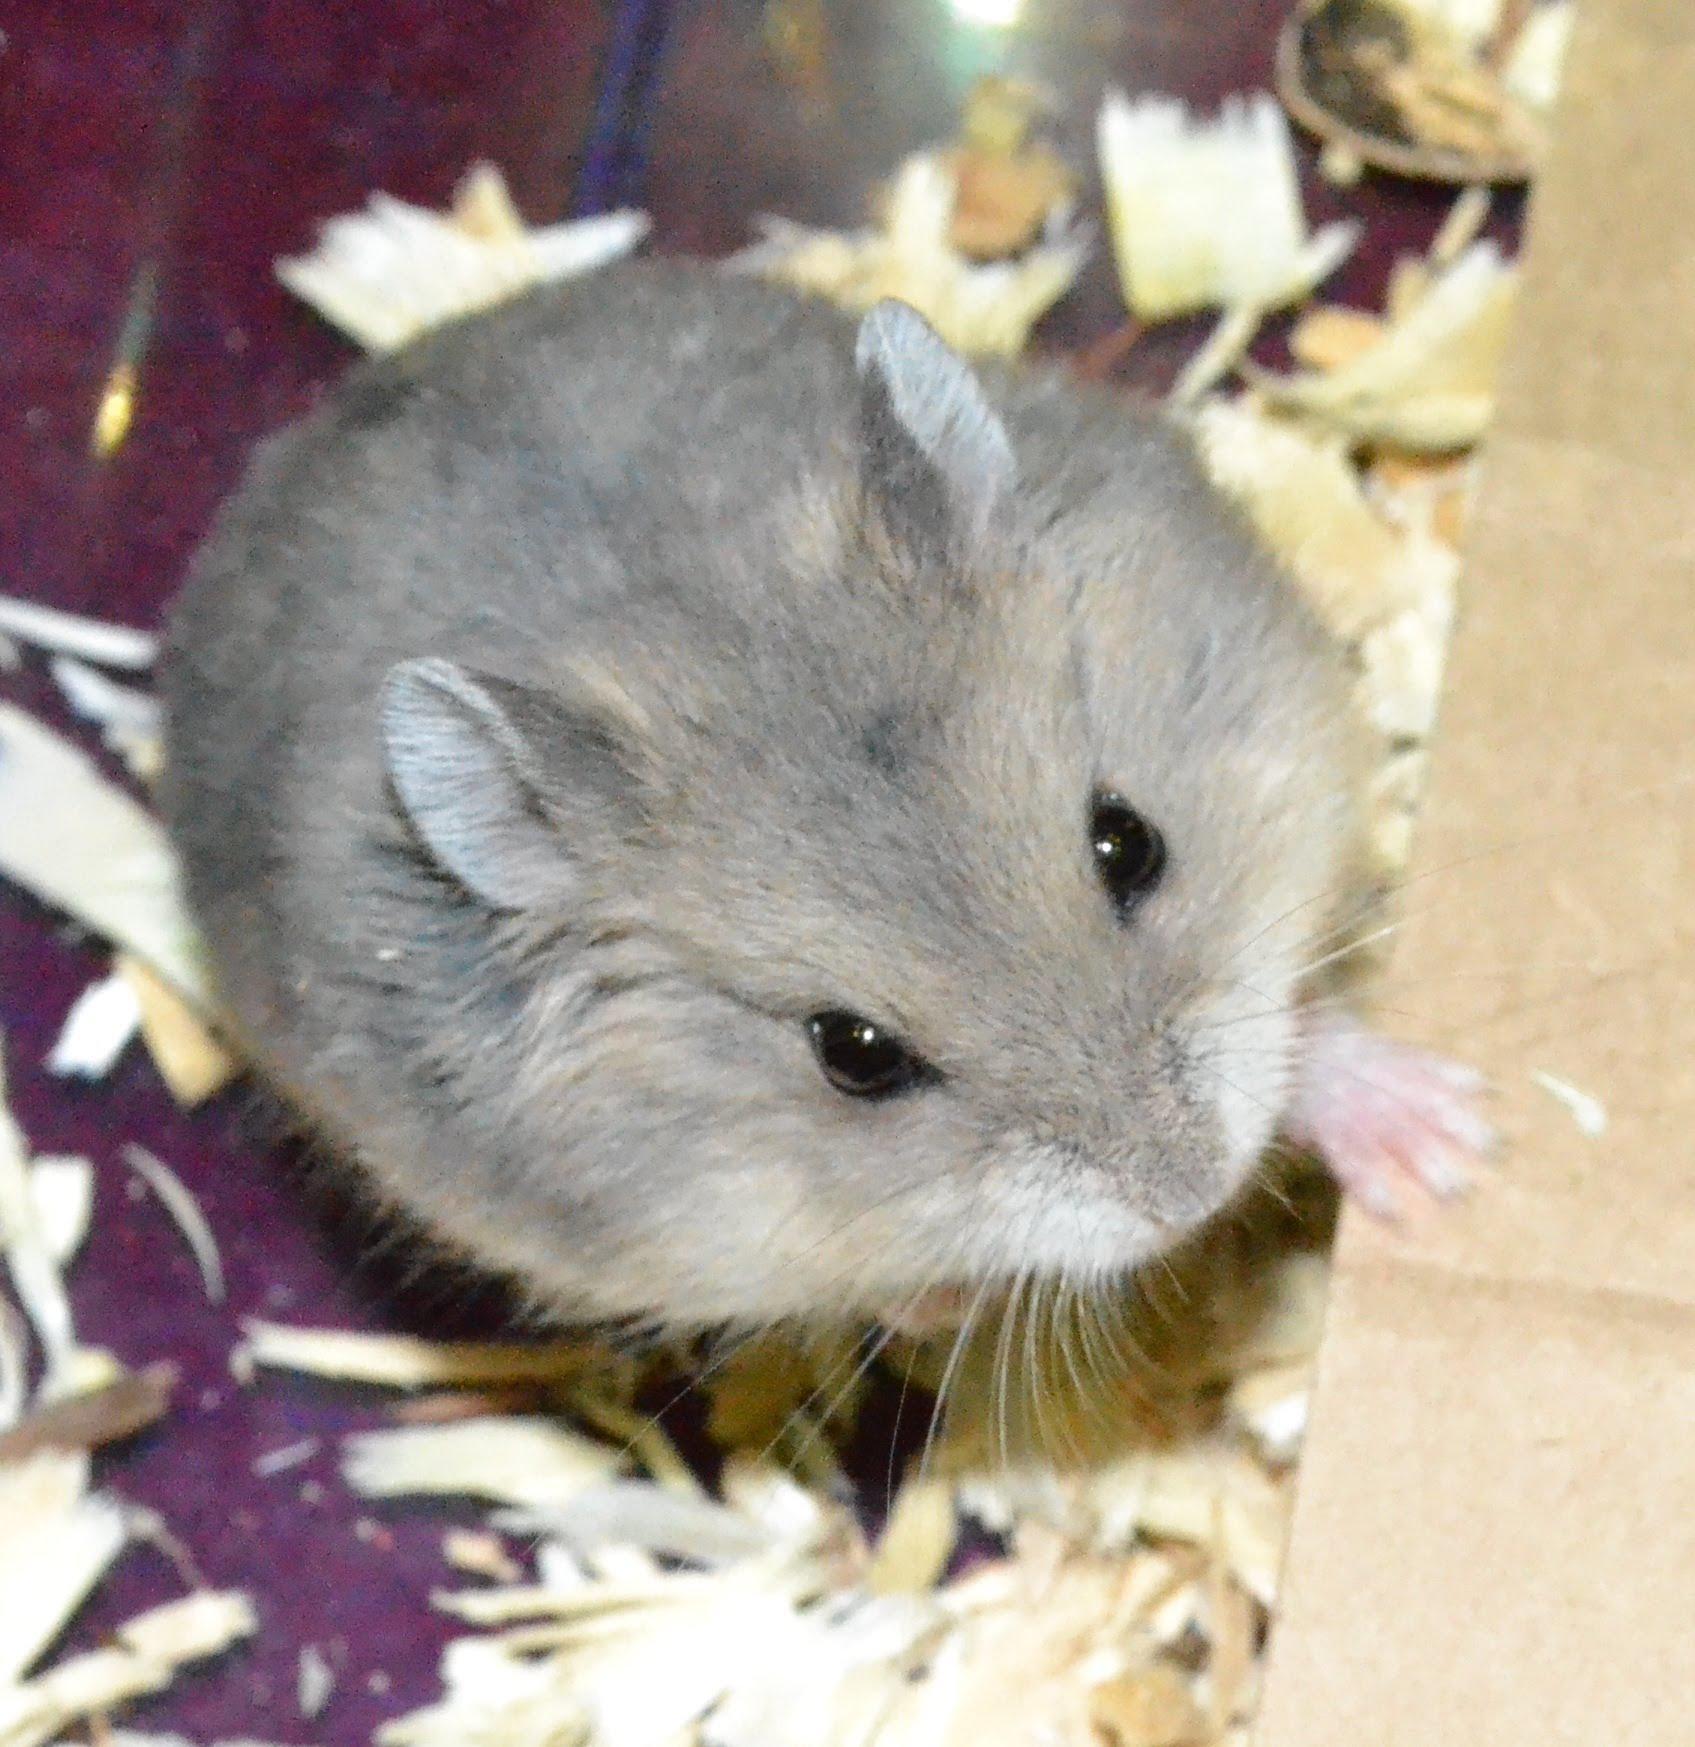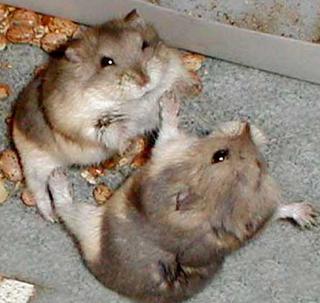The first image is the image on the left, the second image is the image on the right. Examine the images to the left and right. Is the description "There are two pairs of hamsters" accurate? Answer yes or no. No. The first image is the image on the left, the second image is the image on the right. For the images displayed, is the sentence "Cupped hands hold at least one pet rodent in one image." factually correct? Answer yes or no. No. 